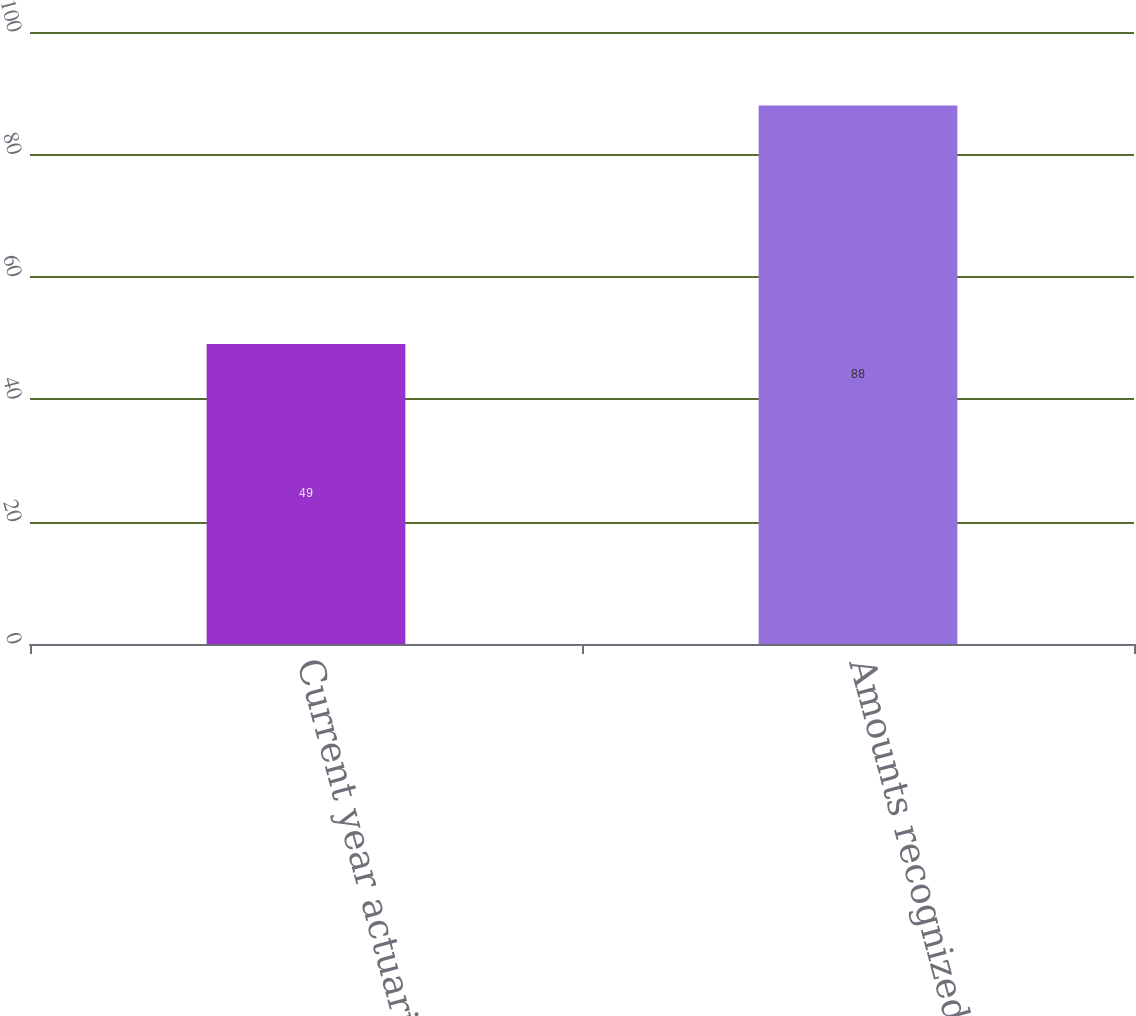<chart> <loc_0><loc_0><loc_500><loc_500><bar_chart><fcel>Current year actuarial (gain)<fcel>Amounts recognized in OCI<nl><fcel>49<fcel>88<nl></chart> 